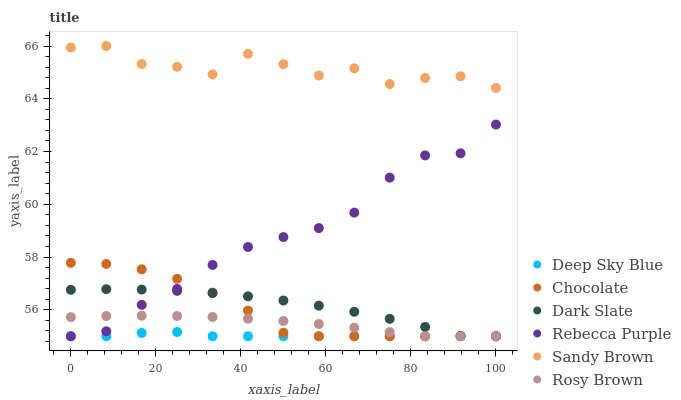Does Deep Sky Blue have the minimum area under the curve?
Answer yes or no. Yes. Does Sandy Brown have the maximum area under the curve?
Answer yes or no. Yes. Does Chocolate have the minimum area under the curve?
Answer yes or no. No. Does Chocolate have the maximum area under the curve?
Answer yes or no. No. Is Rosy Brown the smoothest?
Answer yes or no. Yes. Is Sandy Brown the roughest?
Answer yes or no. Yes. Is Chocolate the smoothest?
Answer yes or no. No. Is Chocolate the roughest?
Answer yes or no. No. Does Rosy Brown have the lowest value?
Answer yes or no. Yes. Does Sandy Brown have the lowest value?
Answer yes or no. No. Does Sandy Brown have the highest value?
Answer yes or no. Yes. Does Chocolate have the highest value?
Answer yes or no. No. Is Deep Sky Blue less than Sandy Brown?
Answer yes or no. Yes. Is Sandy Brown greater than Chocolate?
Answer yes or no. Yes. Does Dark Slate intersect Chocolate?
Answer yes or no. Yes. Is Dark Slate less than Chocolate?
Answer yes or no. No. Is Dark Slate greater than Chocolate?
Answer yes or no. No. Does Deep Sky Blue intersect Sandy Brown?
Answer yes or no. No. 